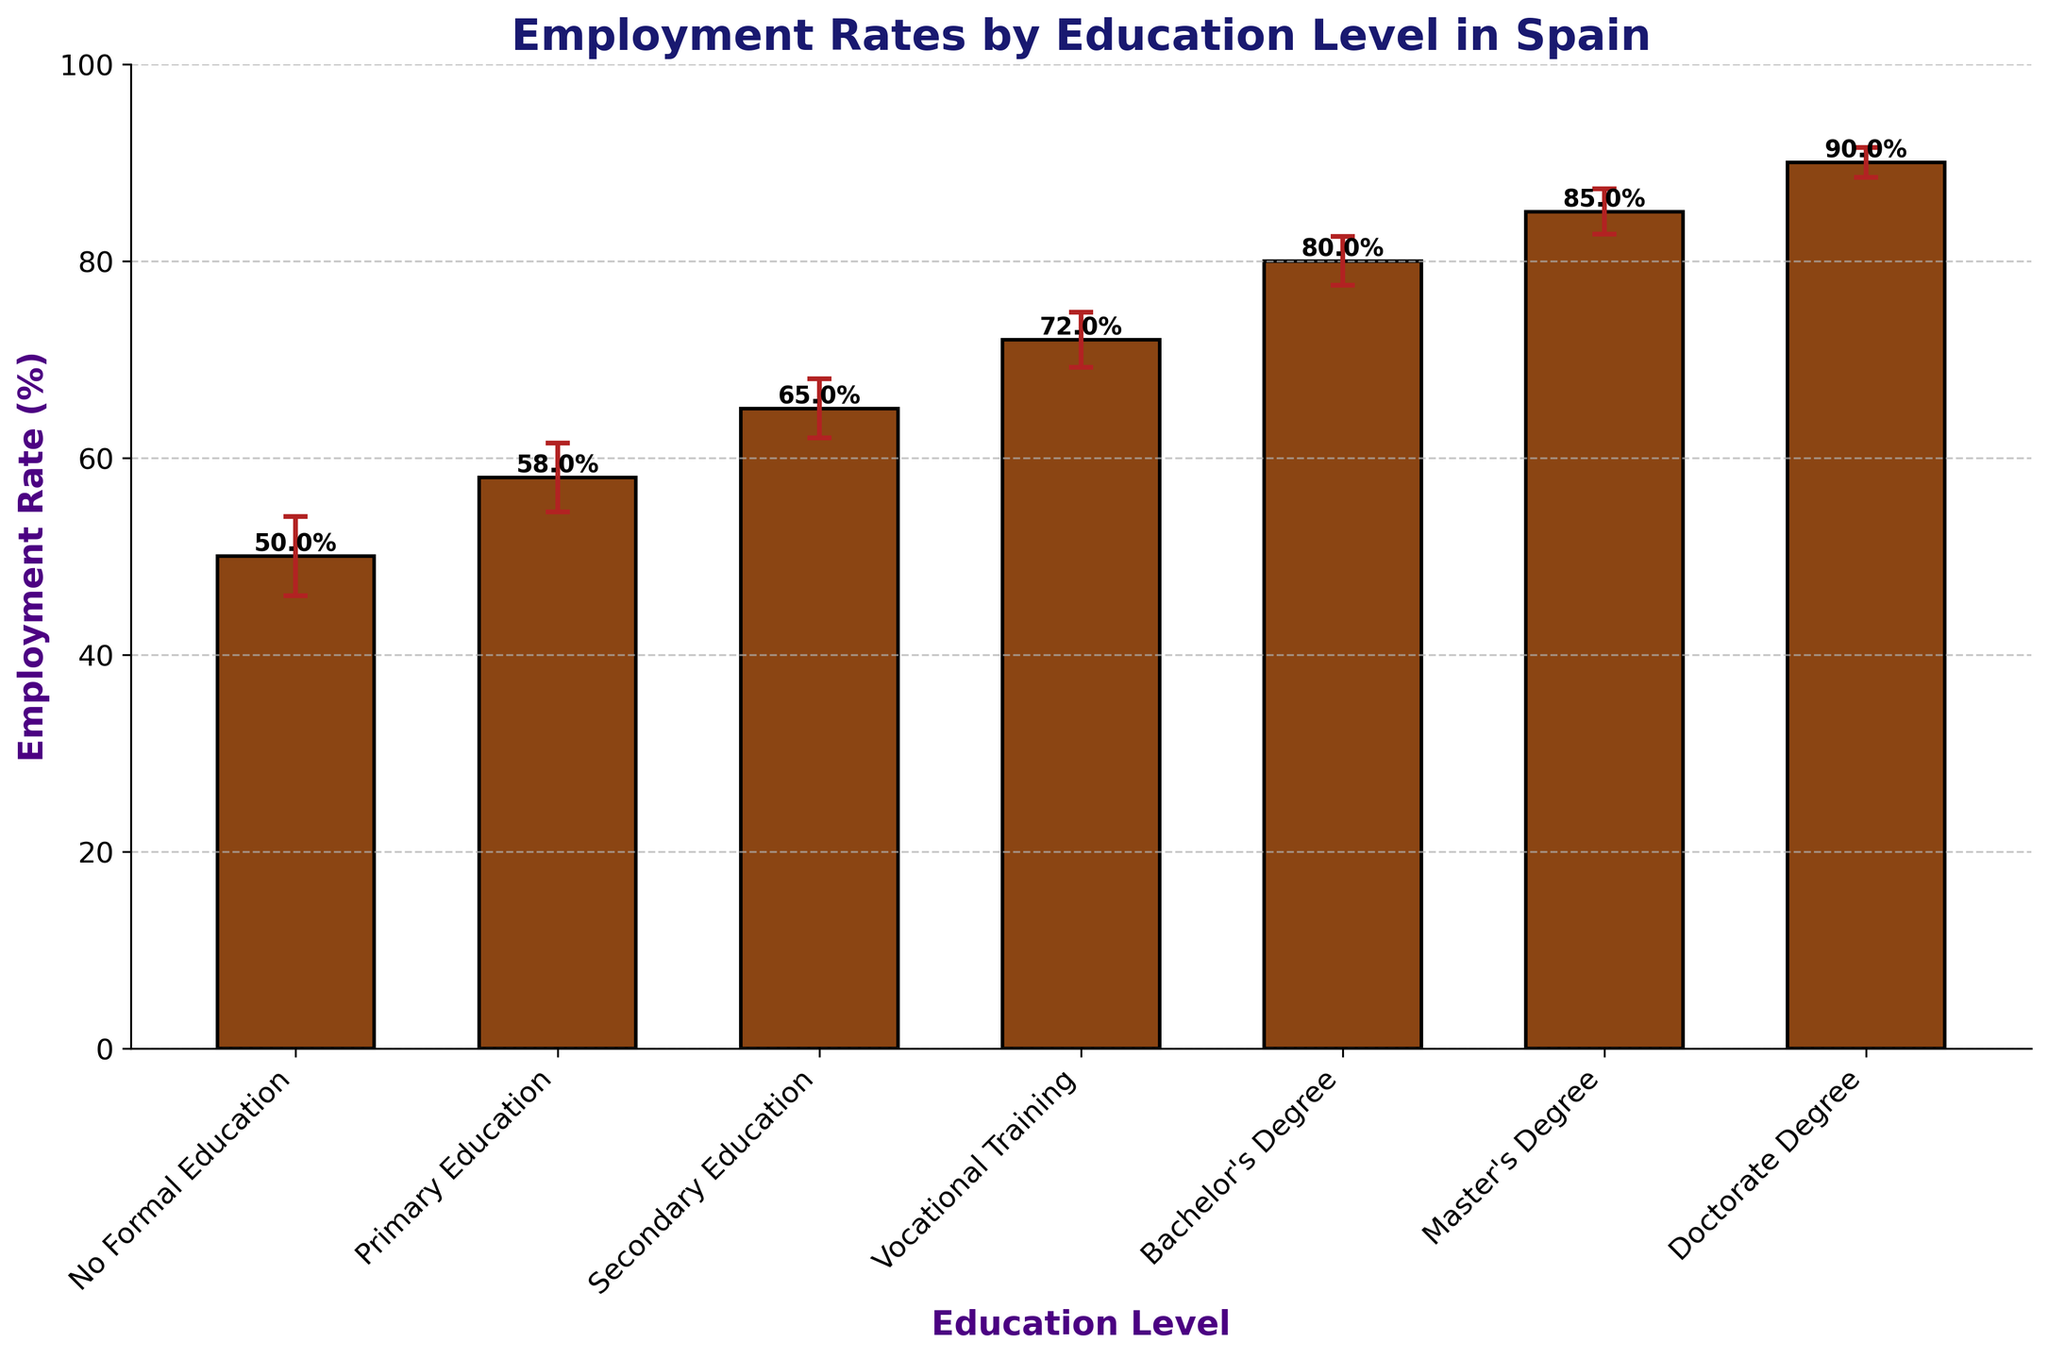What's the employment rate for those with a Bachelor's Degree? The figure shows different employment rates for various education levels. Locate the bar associated with a Bachelor's Degree and read the value.
Answer: 80% What is the title of the chart? The title is usually located at the top of the chart and provides a summary of the data presented.
Answer: Employment Rates by Education Level in Spain How many education levels are represented in the chart? Count the number of bars or distinct x-axis labels in the chart.
Answer: 7 Which education level has the highest employment rate? Compare the height of all the bars to see which one is the tallest.
Answer: Doctorate Degree What is the difference in employment rates between Primary Education and Master's Degree? Locate the employment rates for both Primary Education (58%) and Master's Degree (85%), then subtract the former from the latter.
Answer: 27% Which education level has the largest error margin? Refer to the error bars on each column; the largest margin will have the longest error bar.
Answer: No Formal Education What is the error margin for Secondary Education? Look at the error bar on the column representing Secondary Education and read its value.
Answer: 3% Is the employment rate for Vocational Training higher or lower than for Secondary Education? Compare the heights of the bars. The employment rate for Vocational Training is 72%, while for Secondary Education, it is 65%.
Answer: Higher By how much does the employment rate for Master's Degree exceed that for No Formal Education? Subtract the employment rate for No Formal Education (50%) from the employment rate for Master's Degree (85%).
Answer: 35% What is the average employment rate for primary and secondary education levels? Add the employment rates for Primary (58%) and Secondary Education (65%), then divide by two to find the average.
Answer: 61.5% 